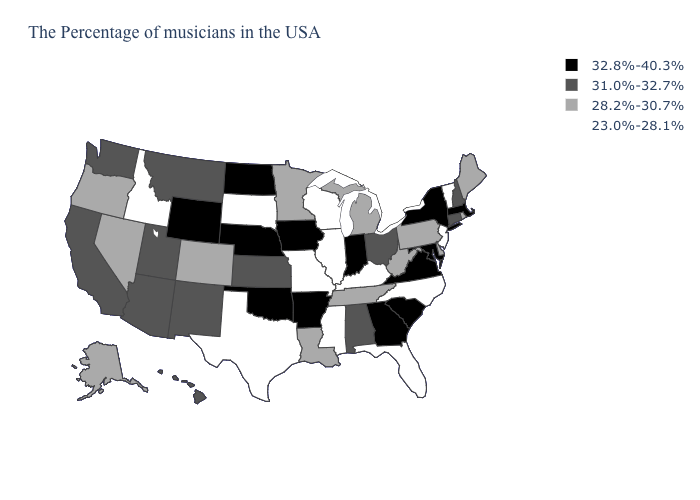What is the value of Utah?
Concise answer only. 31.0%-32.7%. Which states have the highest value in the USA?
Short answer required. Massachusetts, New York, Maryland, Virginia, South Carolina, Georgia, Indiana, Arkansas, Iowa, Nebraska, Oklahoma, North Dakota, Wyoming. What is the value of Mississippi?
Quick response, please. 23.0%-28.1%. What is the value of Delaware?
Quick response, please. 28.2%-30.7%. Name the states that have a value in the range 23.0%-28.1%?
Quick response, please. Vermont, New Jersey, North Carolina, Florida, Kentucky, Wisconsin, Illinois, Mississippi, Missouri, Texas, South Dakota, Idaho. Name the states that have a value in the range 28.2%-30.7%?
Concise answer only. Maine, Rhode Island, Delaware, Pennsylvania, West Virginia, Michigan, Tennessee, Louisiana, Minnesota, Colorado, Nevada, Oregon, Alaska. Among the states that border New Jersey , does New York have the lowest value?
Write a very short answer. No. Which states have the highest value in the USA?
Write a very short answer. Massachusetts, New York, Maryland, Virginia, South Carolina, Georgia, Indiana, Arkansas, Iowa, Nebraska, Oklahoma, North Dakota, Wyoming. What is the value of West Virginia?
Keep it brief. 28.2%-30.7%. Which states have the lowest value in the South?
Keep it brief. North Carolina, Florida, Kentucky, Mississippi, Texas. What is the value of Idaho?
Be succinct. 23.0%-28.1%. Does Ohio have the highest value in the MidWest?
Write a very short answer. No. Name the states that have a value in the range 32.8%-40.3%?
Short answer required. Massachusetts, New York, Maryland, Virginia, South Carolina, Georgia, Indiana, Arkansas, Iowa, Nebraska, Oklahoma, North Dakota, Wyoming. Is the legend a continuous bar?
Quick response, please. No. What is the value of Arizona?
Answer briefly. 31.0%-32.7%. 